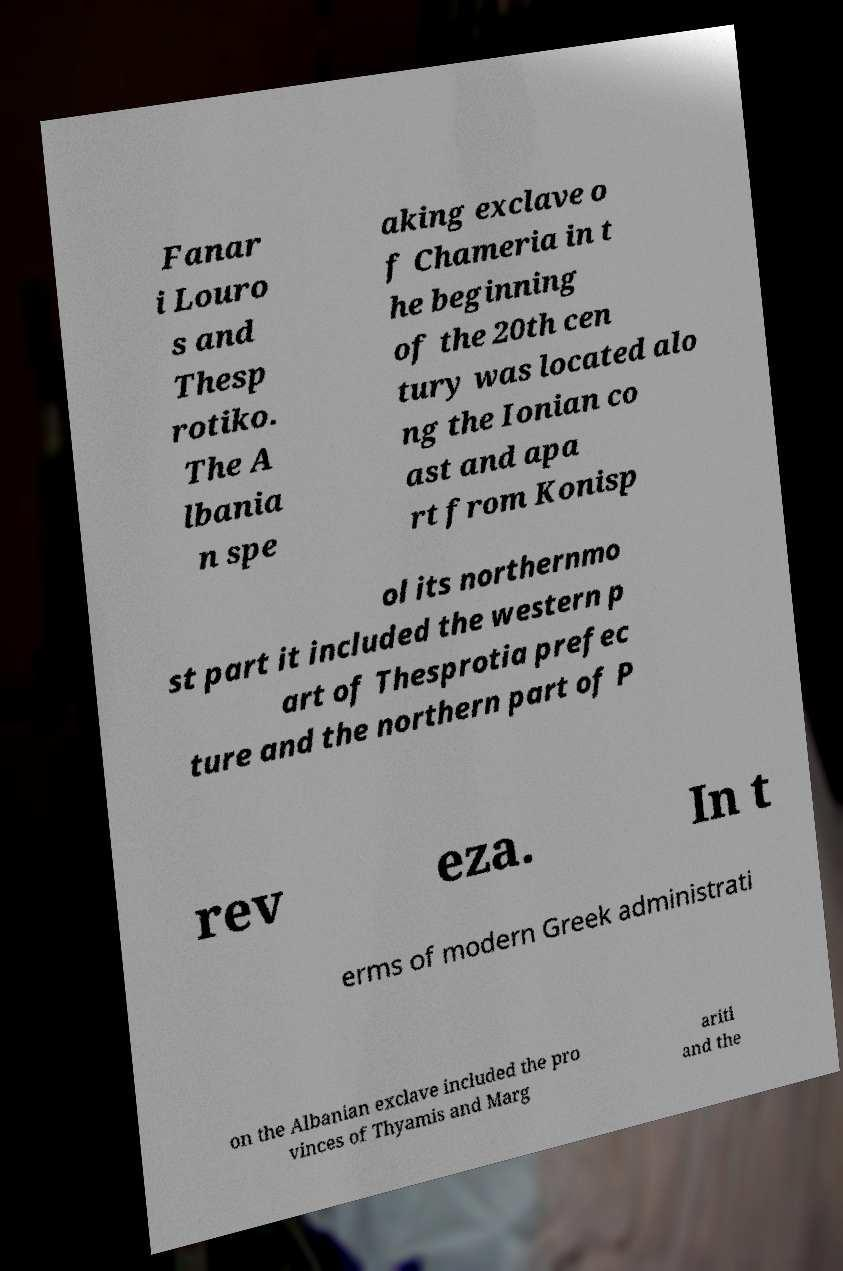Can you accurately transcribe the text from the provided image for me? Fanar i Louro s and Thesp rotiko. The A lbania n spe aking exclave o f Chameria in t he beginning of the 20th cen tury was located alo ng the Ionian co ast and apa rt from Konisp ol its northernmo st part it included the western p art of Thesprotia prefec ture and the northern part of P rev eza. In t erms of modern Greek administrati on the Albanian exclave included the pro vinces of Thyamis and Marg ariti and the 